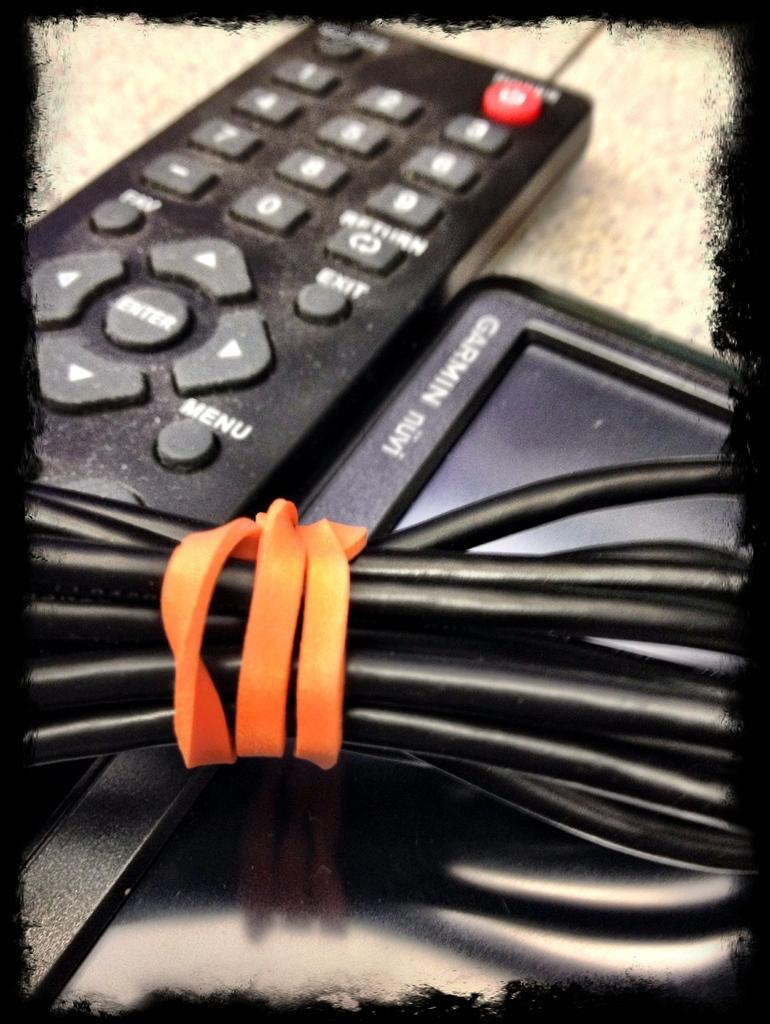<image>
Describe the image concisely. a remote next to a small screen that says 'garmin' on it 